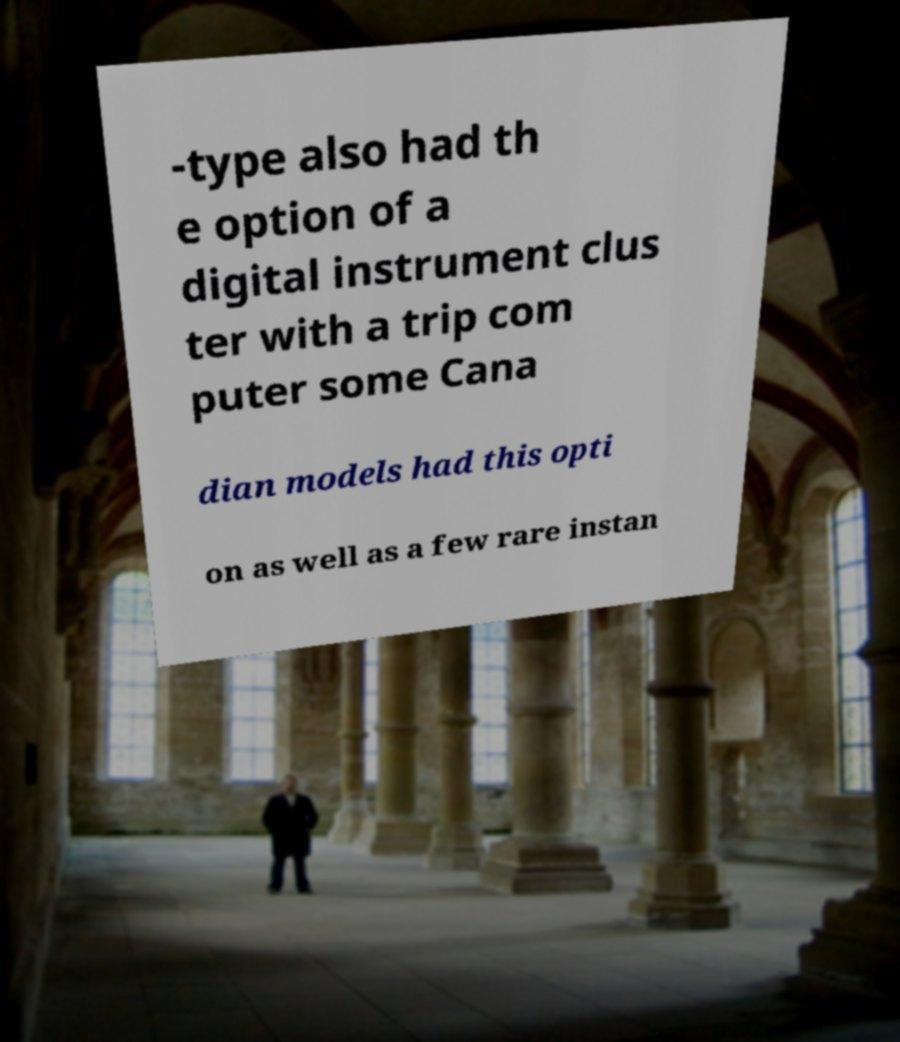There's text embedded in this image that I need extracted. Can you transcribe it verbatim? -type also had th e option of a digital instrument clus ter with a trip com puter some Cana dian models had this opti on as well as a few rare instan 